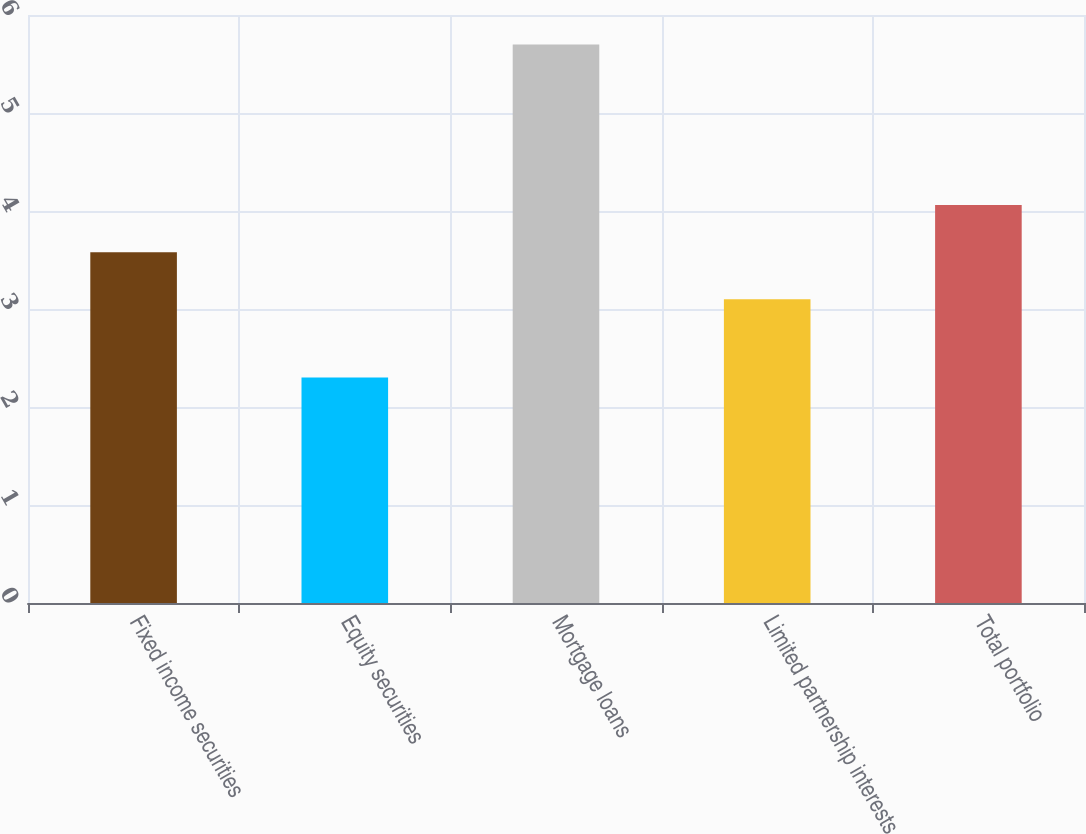<chart> <loc_0><loc_0><loc_500><loc_500><bar_chart><fcel>Fixed income securities<fcel>Equity securities<fcel>Mortgage loans<fcel>Limited partnership interests<fcel>Total portfolio<nl><fcel>3.58<fcel>2.3<fcel>5.7<fcel>3.1<fcel>4.06<nl></chart> 